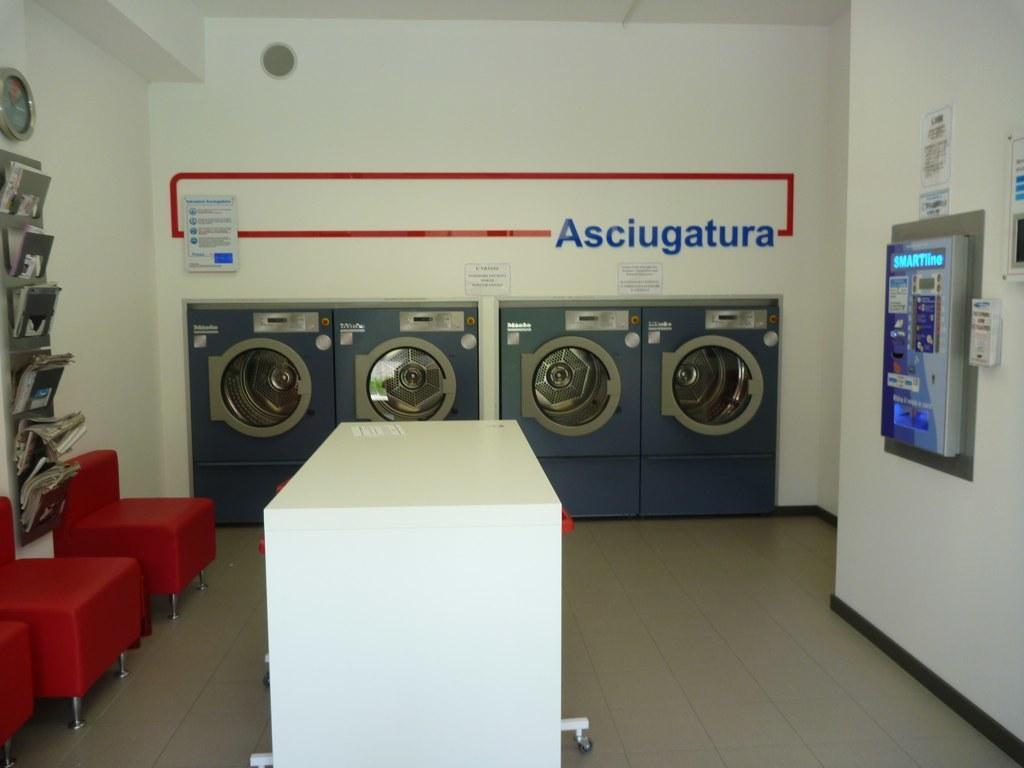Can you describe this image briefly? In this picture we can see a few chairs, books on the shelves and a wall clock on the left side. There is a table. We can see a few posters, grey and white objects on the wall on the right side. There is a poster and a text on the wall. 